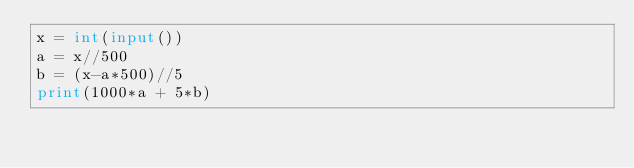<code> <loc_0><loc_0><loc_500><loc_500><_Python_>x = int(input())
a = x//500
b = (x-a*500)//5
print(1000*a + 5*b)</code> 